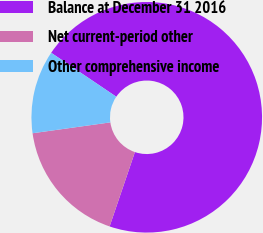Convert chart. <chart><loc_0><loc_0><loc_500><loc_500><pie_chart><fcel>Balance at December 31 2016<fcel>Net current-period other<fcel>Other comprehensive income<nl><fcel>70.77%<fcel>17.57%<fcel>11.66%<nl></chart> 